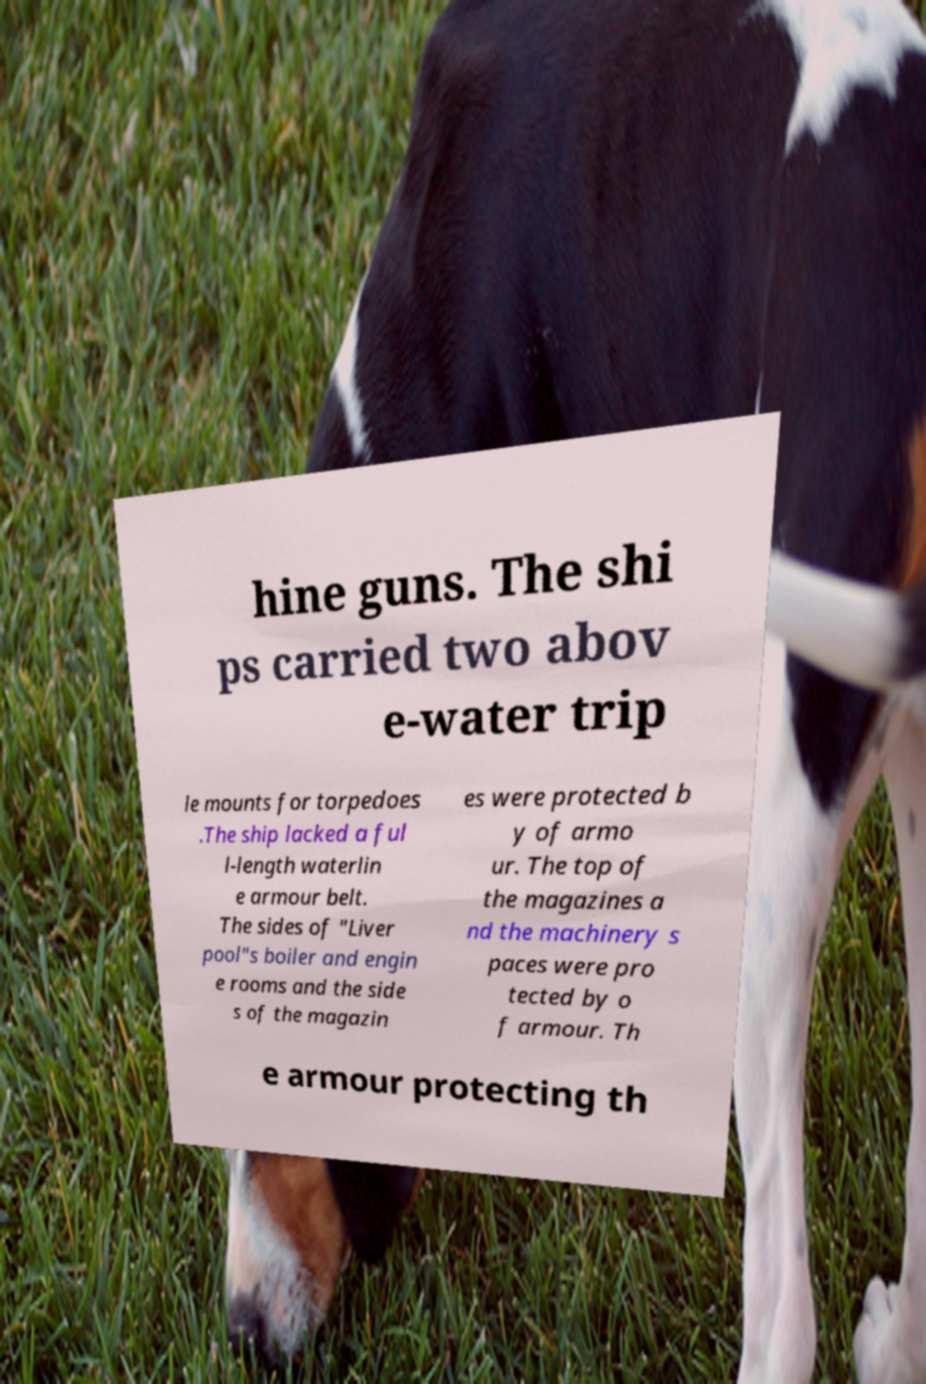Could you assist in decoding the text presented in this image and type it out clearly? hine guns. The shi ps carried two abov e-water trip le mounts for torpedoes .The ship lacked a ful l-length waterlin e armour belt. The sides of "Liver pool"s boiler and engin e rooms and the side s of the magazin es were protected b y of armo ur. The top of the magazines a nd the machinery s paces were pro tected by o f armour. Th e armour protecting th 